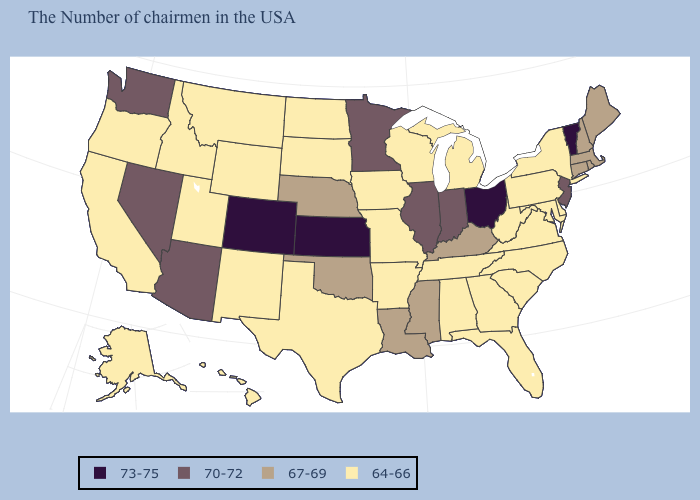What is the highest value in states that border New Jersey?
Answer briefly. 64-66. How many symbols are there in the legend?
Give a very brief answer. 4. What is the value of South Carolina?
Give a very brief answer. 64-66. Does Louisiana have the lowest value in the South?
Give a very brief answer. No. Which states have the lowest value in the MidWest?
Write a very short answer. Michigan, Wisconsin, Missouri, Iowa, South Dakota, North Dakota. Does Idaho have the lowest value in the USA?
Quick response, please. Yes. Name the states that have a value in the range 70-72?
Concise answer only. New Jersey, Indiana, Illinois, Minnesota, Arizona, Nevada, Washington. Which states hav the highest value in the West?
Short answer required. Colorado. Does Kentucky have the highest value in the South?
Write a very short answer. Yes. Which states hav the highest value in the West?
Be succinct. Colorado. Name the states that have a value in the range 67-69?
Answer briefly. Maine, Massachusetts, Rhode Island, New Hampshire, Connecticut, Kentucky, Mississippi, Louisiana, Nebraska, Oklahoma. What is the value of California?
Write a very short answer. 64-66. Name the states that have a value in the range 64-66?
Quick response, please. New York, Delaware, Maryland, Pennsylvania, Virginia, North Carolina, South Carolina, West Virginia, Florida, Georgia, Michigan, Alabama, Tennessee, Wisconsin, Missouri, Arkansas, Iowa, Texas, South Dakota, North Dakota, Wyoming, New Mexico, Utah, Montana, Idaho, California, Oregon, Alaska, Hawaii. What is the value of Illinois?
Short answer required. 70-72. 